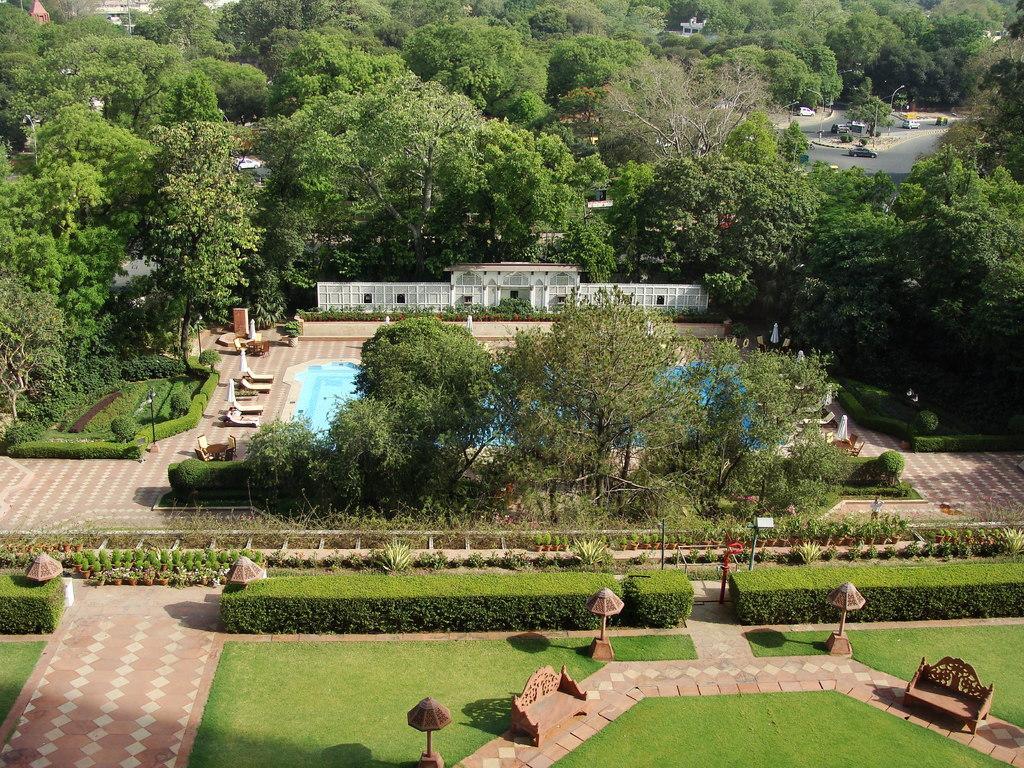Can you describe this image briefly? In this image I can see trees and building and swimming pole in the middle ,at the bottom I can see bench and grass and bushes and plants and flower pot visible and I can see a road visible in the top right. 